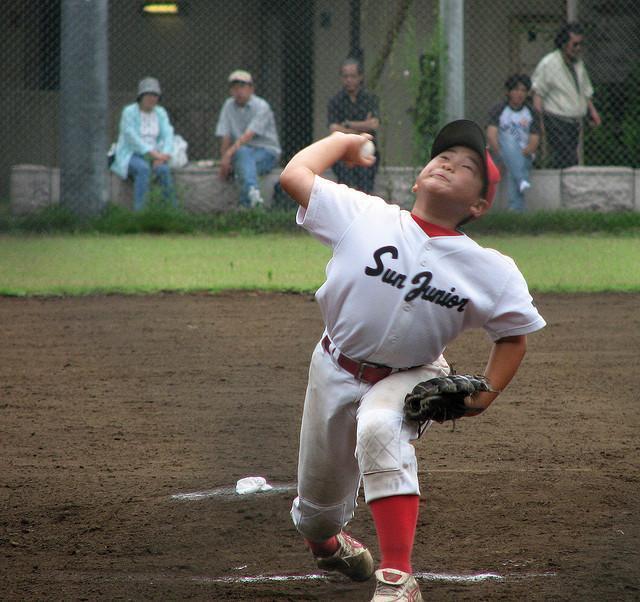Where in the world is this being played?
Pick the right solution, then justify: 'Answer: answer
Rationale: rationale.'
Options: Canada, asia, africa, south america. Answer: asia.
Rationale: The man is asian 